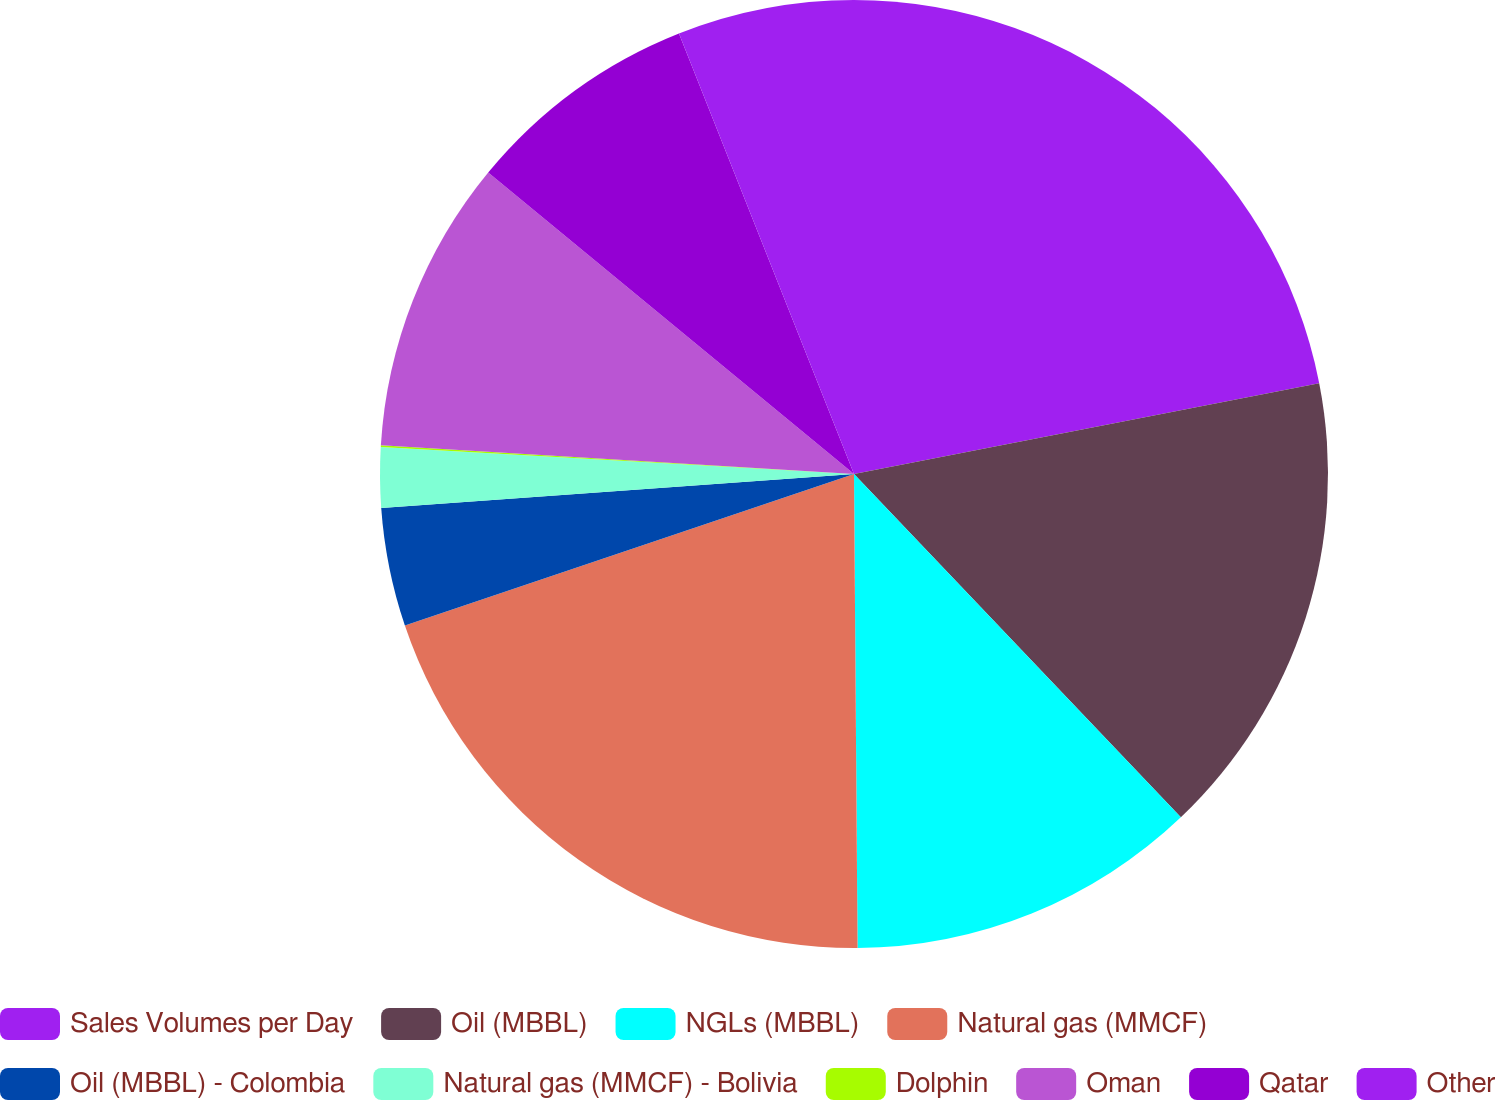<chart> <loc_0><loc_0><loc_500><loc_500><pie_chart><fcel>Sales Volumes per Day<fcel>Oil (MBBL)<fcel>NGLs (MBBL)<fcel>Natural gas (MMCF)<fcel>Oil (MBBL) - Colombia<fcel>Natural gas (MMCF) - Bolivia<fcel>Dolphin<fcel>Oman<fcel>Qatar<fcel>Other<nl><fcel>21.93%<fcel>15.96%<fcel>11.99%<fcel>19.94%<fcel>4.04%<fcel>2.05%<fcel>0.06%<fcel>10.0%<fcel>8.01%<fcel>6.02%<nl></chart> 